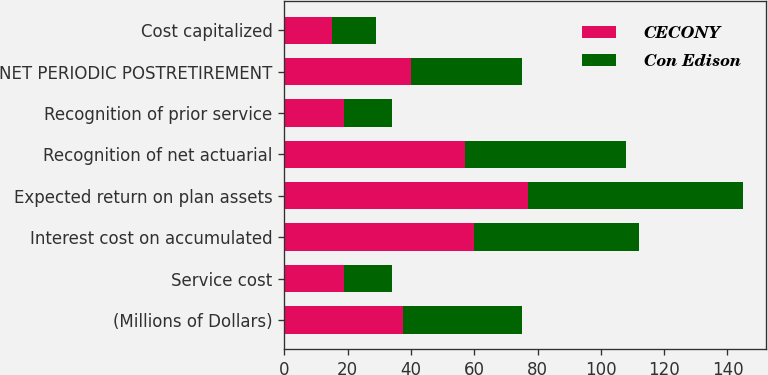<chart> <loc_0><loc_0><loc_500><loc_500><stacked_bar_chart><ecel><fcel>(Millions of Dollars)<fcel>Service cost<fcel>Interest cost on accumulated<fcel>Expected return on plan assets<fcel>Recognition of net actuarial<fcel>Recognition of prior service<fcel>NET PERIODIC POSTRETIREMENT<fcel>Cost capitalized<nl><fcel>CECONY<fcel>37.5<fcel>19<fcel>60<fcel>77<fcel>57<fcel>19<fcel>40<fcel>15<nl><fcel>Con Edison<fcel>37.5<fcel>15<fcel>52<fcel>68<fcel>51<fcel>15<fcel>35<fcel>14<nl></chart> 